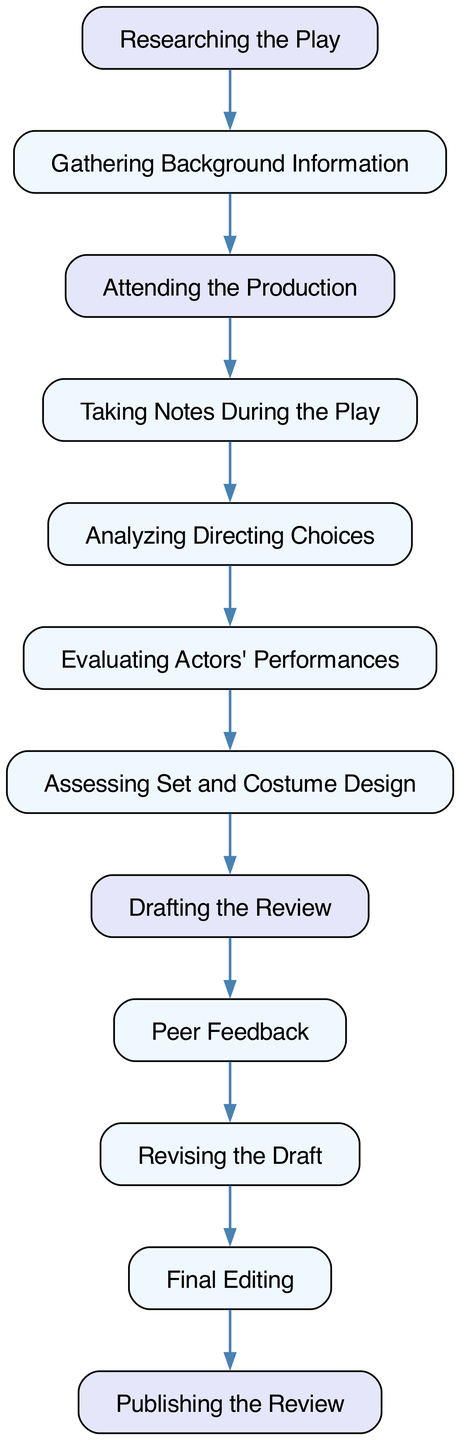What is the first step in the review process? The first step in the review process is "Researching the Play," which is the initial activity in the flow of tasks that lead to the publication of the review.
Answer: Researching the Play How many activities are there in total? By counting all the activities listed in the diagram, we see there are 11 distinct activities that contribute to the review process.
Answer: 11 What is the last activity before publishing the review? The last activity before "Publishing the Review" is "Final Editing," which is crucial to ensure the review is polished before being made public.
Answer: Final Editing Which two activities are directly connected? "Assessing Set and Costume Design" and "Drafting the Review" are directly connected, indicating that the assessment feeds into the drafting process.
Answer: Assessing Set and Costume Design and Drafting the Review What activity follows "Peer Feedback"? The activity that follows "Peer Feedback" is "Revising the Draft," suggesting that feedback will lead to changes and improvements in the initial draft of the review.
Answer: Revising the Draft Which activity evaluates actors' performances? The activity that evaluates the actors' performances is specifically labelled as "Evaluating Actors' Performances," highlighting its importance in the review process.
Answer: Evaluating Actors' Performances Which activity comes right before "Final Editing"? The activity that comes right before "Final Editing" is "Revising the Draft," indicating that revisions must occur before finalization.
Answer: Revising the Draft How many flows are in the diagram? There are 10 flows connecting the various activities, illustrating the sequence and dependency among them in the reviewing process.
Answer: 10 What type of diagram is this? This is an Activity Diagram, which illustrates the flow of activities involved in writing and editing a theater review.
Answer: Activity Diagram 